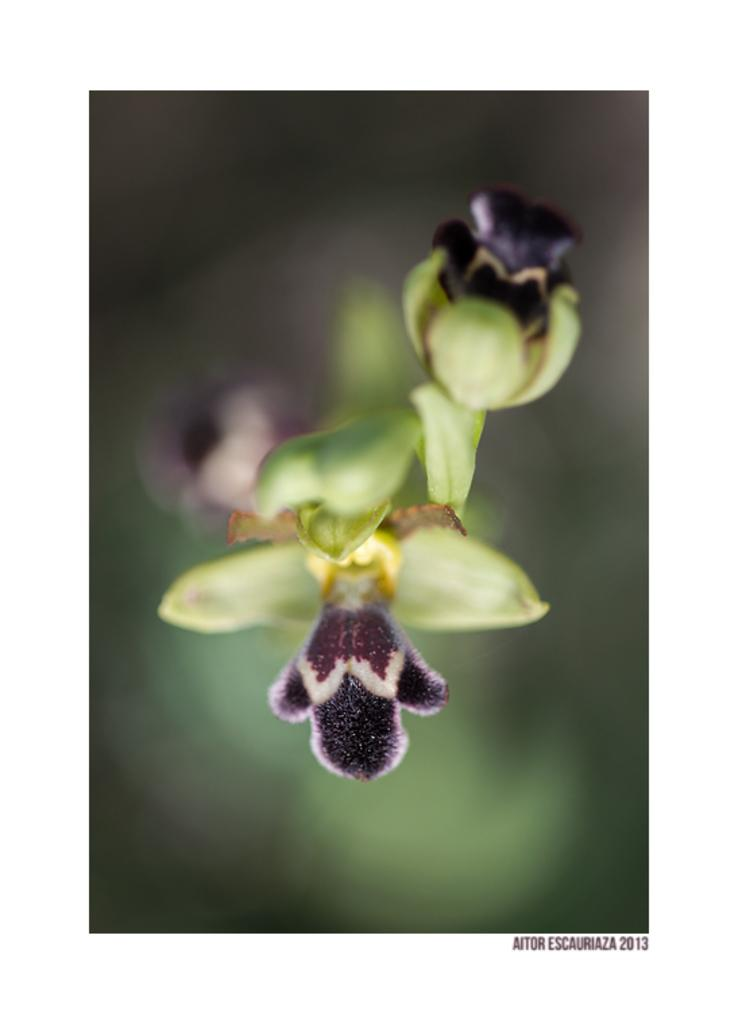What is present in the image? There are buds in the image. Can you describe the background of the image? The background of the image is blurred. How many dimes are scattered around the cemetery in the image? There is no cemetery or dimes present in the image; it only features buds with a blurred background. 